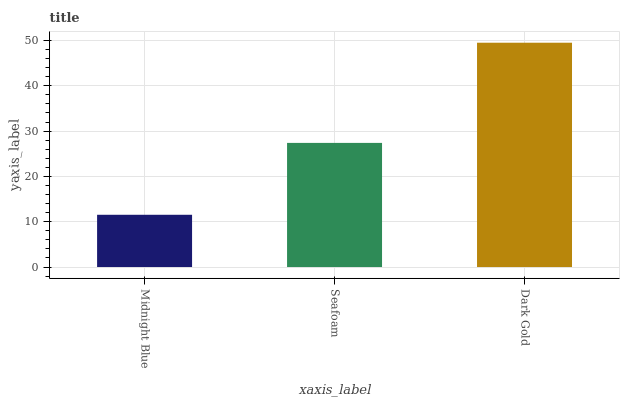Is Midnight Blue the minimum?
Answer yes or no. Yes. Is Dark Gold the maximum?
Answer yes or no. Yes. Is Seafoam the minimum?
Answer yes or no. No. Is Seafoam the maximum?
Answer yes or no. No. Is Seafoam greater than Midnight Blue?
Answer yes or no. Yes. Is Midnight Blue less than Seafoam?
Answer yes or no. Yes. Is Midnight Blue greater than Seafoam?
Answer yes or no. No. Is Seafoam less than Midnight Blue?
Answer yes or no. No. Is Seafoam the high median?
Answer yes or no. Yes. Is Seafoam the low median?
Answer yes or no. Yes. Is Midnight Blue the high median?
Answer yes or no. No. Is Dark Gold the low median?
Answer yes or no. No. 